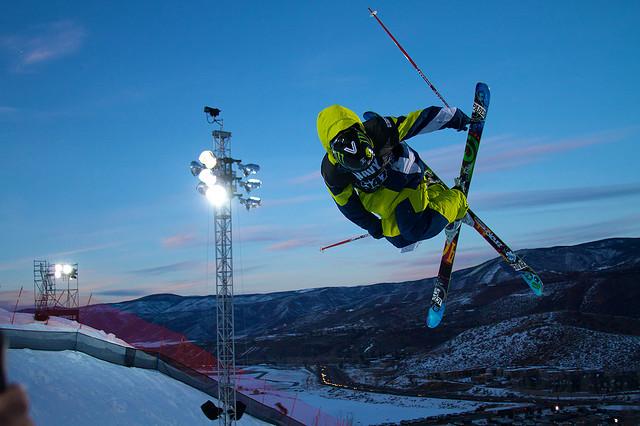Is the man snowboarding?
Answer briefly. No. Is the man in the air?
Write a very short answer. Yes. What time was the pic taken?
Write a very short answer. Night. 